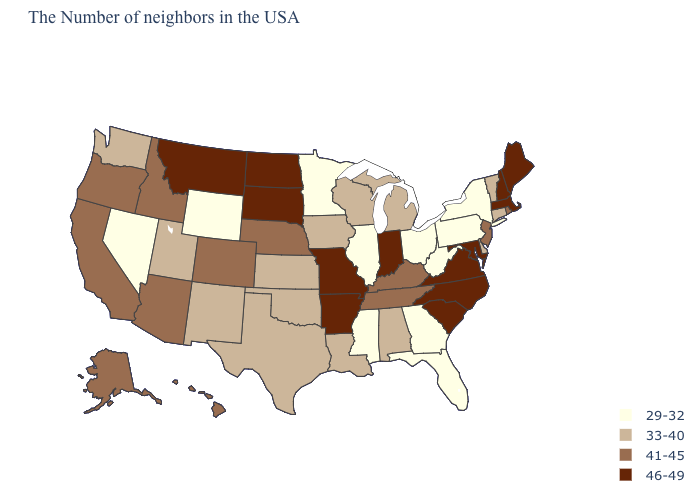Does West Virginia have a higher value than Utah?
Give a very brief answer. No. Does Minnesota have the same value as Pennsylvania?
Be succinct. Yes. What is the value of Iowa?
Concise answer only. 33-40. Name the states that have a value in the range 29-32?
Give a very brief answer. New York, Pennsylvania, West Virginia, Ohio, Florida, Georgia, Illinois, Mississippi, Minnesota, Wyoming, Nevada. What is the highest value in the USA?
Give a very brief answer. 46-49. Name the states that have a value in the range 46-49?
Concise answer only. Maine, Massachusetts, New Hampshire, Maryland, Virginia, North Carolina, South Carolina, Indiana, Missouri, Arkansas, South Dakota, North Dakota, Montana. What is the value of Colorado?
Be succinct. 41-45. Does the first symbol in the legend represent the smallest category?
Concise answer only. Yes. Name the states that have a value in the range 46-49?
Write a very short answer. Maine, Massachusetts, New Hampshire, Maryland, Virginia, North Carolina, South Carolina, Indiana, Missouri, Arkansas, South Dakota, North Dakota, Montana. Does Louisiana have the lowest value in the South?
Concise answer only. No. Which states have the lowest value in the West?
Keep it brief. Wyoming, Nevada. Name the states that have a value in the range 29-32?
Concise answer only. New York, Pennsylvania, West Virginia, Ohio, Florida, Georgia, Illinois, Mississippi, Minnesota, Wyoming, Nevada. What is the highest value in the West ?
Keep it brief. 46-49. Which states have the highest value in the USA?
Keep it brief. Maine, Massachusetts, New Hampshire, Maryland, Virginia, North Carolina, South Carolina, Indiana, Missouri, Arkansas, South Dakota, North Dakota, Montana. Does Hawaii have the lowest value in the USA?
Be succinct. No. 